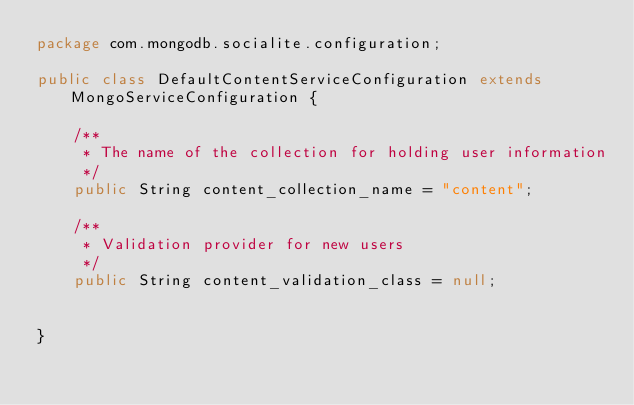<code> <loc_0><loc_0><loc_500><loc_500><_Java_>package com.mongodb.socialite.configuration;

public class DefaultContentServiceConfiguration extends MongoServiceConfiguration {
	
	/**
	 * The name of the collection for holding user information
	 */
	public String content_collection_name = "content";
	
	/**
	 * Validation provider for new users
	 */
	public String content_validation_class = null;
	

}
</code> 